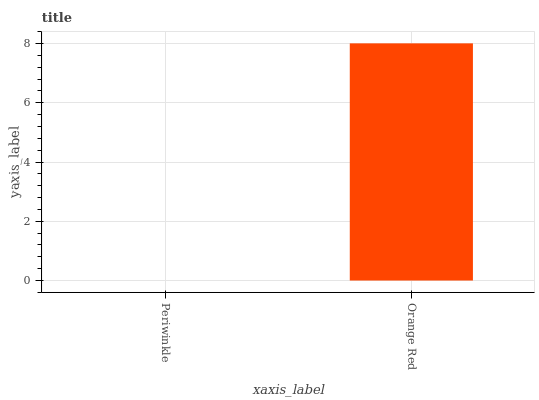Is Periwinkle the minimum?
Answer yes or no. Yes. Is Orange Red the maximum?
Answer yes or no. Yes. Is Orange Red the minimum?
Answer yes or no. No. Is Orange Red greater than Periwinkle?
Answer yes or no. Yes. Is Periwinkle less than Orange Red?
Answer yes or no. Yes. Is Periwinkle greater than Orange Red?
Answer yes or no. No. Is Orange Red less than Periwinkle?
Answer yes or no. No. Is Orange Red the high median?
Answer yes or no. Yes. Is Periwinkle the low median?
Answer yes or no. Yes. Is Periwinkle the high median?
Answer yes or no. No. Is Orange Red the low median?
Answer yes or no. No. 